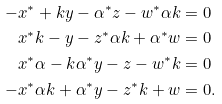<formula> <loc_0><loc_0><loc_500><loc_500>- x ^ { * } + k y - \alpha ^ { * } z - w ^ { * } \alpha k & = 0 \\ x ^ { * } k - y - z ^ { * } \alpha k + \alpha ^ { * } w & = 0 \\ x ^ { * } \alpha - k \alpha ^ { * } y - z - w ^ { * } k & = 0 \\ - x ^ { * } \alpha k + \alpha ^ { * } y - z ^ { * } k + w & = 0 .</formula> 